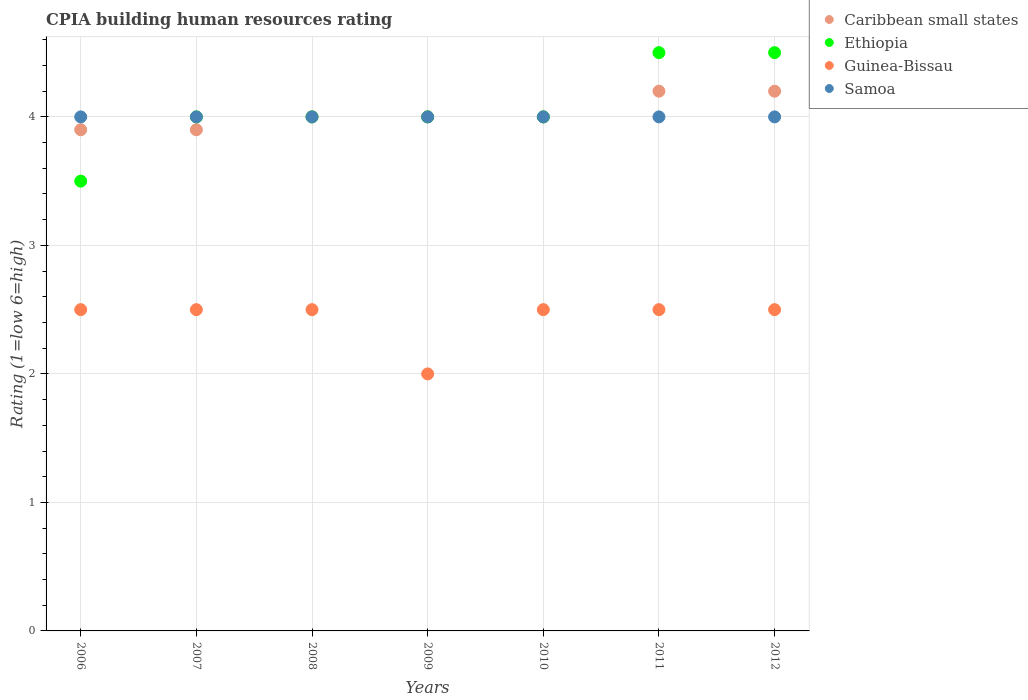How many different coloured dotlines are there?
Provide a succinct answer. 4. Is the number of dotlines equal to the number of legend labels?
Provide a short and direct response. Yes. What is the CPIA rating in Caribbean small states in 2010?
Offer a terse response. 4. Across all years, what is the maximum CPIA rating in Caribbean small states?
Ensure brevity in your answer.  4.2. Across all years, what is the minimum CPIA rating in Ethiopia?
Keep it short and to the point. 3.5. In which year was the CPIA rating in Samoa minimum?
Make the answer very short. 2006. What is the total CPIA rating in Guinea-Bissau in the graph?
Your response must be concise. 17. What is the average CPIA rating in Guinea-Bissau per year?
Your answer should be very brief. 2.43. In the year 2008, what is the difference between the CPIA rating in Guinea-Bissau and CPIA rating in Samoa?
Keep it short and to the point. -1.5. Is the CPIA rating in Ethiopia in 2006 less than that in 2012?
Offer a terse response. Yes. Is the difference between the CPIA rating in Guinea-Bissau in 2006 and 2012 greater than the difference between the CPIA rating in Samoa in 2006 and 2012?
Provide a short and direct response. No. What is the difference between the highest and the second highest CPIA rating in Ethiopia?
Your response must be concise. 0. What is the difference between the highest and the lowest CPIA rating in Guinea-Bissau?
Give a very brief answer. 0.5. Is it the case that in every year, the sum of the CPIA rating in Samoa and CPIA rating in Ethiopia  is greater than the sum of CPIA rating in Guinea-Bissau and CPIA rating in Caribbean small states?
Provide a succinct answer. No. Is it the case that in every year, the sum of the CPIA rating in Ethiopia and CPIA rating in Guinea-Bissau  is greater than the CPIA rating in Caribbean small states?
Your response must be concise. Yes. Does the CPIA rating in Caribbean small states monotonically increase over the years?
Offer a terse response. No. How many years are there in the graph?
Your response must be concise. 7. What is the difference between two consecutive major ticks on the Y-axis?
Offer a terse response. 1. Does the graph contain any zero values?
Offer a terse response. No. Does the graph contain grids?
Provide a succinct answer. Yes. Where does the legend appear in the graph?
Your response must be concise. Top right. How many legend labels are there?
Make the answer very short. 4. How are the legend labels stacked?
Keep it short and to the point. Vertical. What is the title of the graph?
Provide a succinct answer. CPIA building human resources rating. What is the label or title of the X-axis?
Provide a succinct answer. Years. What is the label or title of the Y-axis?
Provide a succinct answer. Rating (1=low 6=high). What is the Rating (1=low 6=high) of Guinea-Bissau in 2007?
Ensure brevity in your answer.  2.5. What is the Rating (1=low 6=high) in Caribbean small states in 2008?
Keep it short and to the point. 4. What is the Rating (1=low 6=high) in Samoa in 2008?
Your answer should be very brief. 4. What is the Rating (1=low 6=high) in Samoa in 2009?
Make the answer very short. 4. What is the Rating (1=low 6=high) in Guinea-Bissau in 2010?
Your response must be concise. 2.5. What is the Rating (1=low 6=high) in Ethiopia in 2011?
Provide a short and direct response. 4.5. What is the Rating (1=low 6=high) of Guinea-Bissau in 2011?
Ensure brevity in your answer.  2.5. What is the Rating (1=low 6=high) in Samoa in 2011?
Your response must be concise. 4. What is the Rating (1=low 6=high) in Guinea-Bissau in 2012?
Offer a very short reply. 2.5. What is the Rating (1=low 6=high) in Samoa in 2012?
Keep it short and to the point. 4. Across all years, what is the maximum Rating (1=low 6=high) of Guinea-Bissau?
Your response must be concise. 2.5. Across all years, what is the maximum Rating (1=low 6=high) of Samoa?
Provide a short and direct response. 4. Across all years, what is the minimum Rating (1=low 6=high) of Caribbean small states?
Your response must be concise. 3.9. Across all years, what is the minimum Rating (1=low 6=high) in Samoa?
Give a very brief answer. 4. What is the total Rating (1=low 6=high) of Caribbean small states in the graph?
Ensure brevity in your answer.  28.2. What is the total Rating (1=low 6=high) in Ethiopia in the graph?
Make the answer very short. 28.5. What is the total Rating (1=low 6=high) in Guinea-Bissau in the graph?
Your answer should be very brief. 17. What is the total Rating (1=low 6=high) in Samoa in the graph?
Offer a very short reply. 28. What is the difference between the Rating (1=low 6=high) of Ethiopia in 2006 and that in 2007?
Your answer should be very brief. -0.5. What is the difference between the Rating (1=low 6=high) of Guinea-Bissau in 2006 and that in 2007?
Provide a short and direct response. 0. What is the difference between the Rating (1=low 6=high) in Caribbean small states in 2006 and that in 2008?
Your answer should be compact. -0.1. What is the difference between the Rating (1=low 6=high) of Ethiopia in 2006 and that in 2008?
Provide a succinct answer. -0.5. What is the difference between the Rating (1=low 6=high) of Samoa in 2006 and that in 2008?
Your answer should be very brief. 0. What is the difference between the Rating (1=low 6=high) in Caribbean small states in 2006 and that in 2009?
Keep it short and to the point. -0.1. What is the difference between the Rating (1=low 6=high) in Ethiopia in 2006 and that in 2009?
Your answer should be very brief. -0.5. What is the difference between the Rating (1=low 6=high) of Samoa in 2006 and that in 2009?
Keep it short and to the point. 0. What is the difference between the Rating (1=low 6=high) of Guinea-Bissau in 2006 and that in 2010?
Offer a terse response. 0. What is the difference between the Rating (1=low 6=high) of Samoa in 2006 and that in 2010?
Ensure brevity in your answer.  0. What is the difference between the Rating (1=low 6=high) in Ethiopia in 2006 and that in 2011?
Your answer should be very brief. -1. What is the difference between the Rating (1=low 6=high) in Samoa in 2006 and that in 2011?
Provide a succinct answer. 0. What is the difference between the Rating (1=low 6=high) in Guinea-Bissau in 2006 and that in 2012?
Ensure brevity in your answer.  0. What is the difference between the Rating (1=low 6=high) in Samoa in 2006 and that in 2012?
Provide a succinct answer. 0. What is the difference between the Rating (1=low 6=high) in Ethiopia in 2007 and that in 2008?
Your response must be concise. 0. What is the difference between the Rating (1=low 6=high) of Samoa in 2007 and that in 2008?
Make the answer very short. 0. What is the difference between the Rating (1=low 6=high) in Caribbean small states in 2007 and that in 2009?
Ensure brevity in your answer.  -0.1. What is the difference between the Rating (1=low 6=high) of Ethiopia in 2007 and that in 2009?
Ensure brevity in your answer.  0. What is the difference between the Rating (1=low 6=high) of Caribbean small states in 2007 and that in 2010?
Give a very brief answer. -0.1. What is the difference between the Rating (1=low 6=high) in Ethiopia in 2007 and that in 2010?
Provide a succinct answer. 0. What is the difference between the Rating (1=low 6=high) of Guinea-Bissau in 2007 and that in 2010?
Your answer should be very brief. 0. What is the difference between the Rating (1=low 6=high) of Samoa in 2007 and that in 2010?
Your response must be concise. 0. What is the difference between the Rating (1=low 6=high) in Caribbean small states in 2007 and that in 2011?
Your answer should be compact. -0.3. What is the difference between the Rating (1=low 6=high) in Guinea-Bissau in 2007 and that in 2011?
Your answer should be very brief. 0. What is the difference between the Rating (1=low 6=high) in Samoa in 2007 and that in 2011?
Your answer should be compact. 0. What is the difference between the Rating (1=low 6=high) of Caribbean small states in 2007 and that in 2012?
Provide a succinct answer. -0.3. What is the difference between the Rating (1=low 6=high) of Ethiopia in 2007 and that in 2012?
Your answer should be compact. -0.5. What is the difference between the Rating (1=low 6=high) in Guinea-Bissau in 2007 and that in 2012?
Your response must be concise. 0. What is the difference between the Rating (1=low 6=high) of Samoa in 2007 and that in 2012?
Your answer should be very brief. 0. What is the difference between the Rating (1=low 6=high) of Caribbean small states in 2008 and that in 2009?
Offer a very short reply. 0. What is the difference between the Rating (1=low 6=high) in Guinea-Bissau in 2008 and that in 2010?
Provide a succinct answer. 0. What is the difference between the Rating (1=low 6=high) of Caribbean small states in 2008 and that in 2011?
Make the answer very short. -0.2. What is the difference between the Rating (1=low 6=high) in Guinea-Bissau in 2008 and that in 2011?
Ensure brevity in your answer.  0. What is the difference between the Rating (1=low 6=high) in Caribbean small states in 2008 and that in 2012?
Give a very brief answer. -0.2. What is the difference between the Rating (1=low 6=high) of Ethiopia in 2008 and that in 2012?
Ensure brevity in your answer.  -0.5. What is the difference between the Rating (1=low 6=high) in Guinea-Bissau in 2008 and that in 2012?
Offer a very short reply. 0. What is the difference between the Rating (1=low 6=high) in Samoa in 2008 and that in 2012?
Offer a terse response. 0. What is the difference between the Rating (1=low 6=high) in Caribbean small states in 2009 and that in 2010?
Make the answer very short. 0. What is the difference between the Rating (1=low 6=high) of Caribbean small states in 2009 and that in 2011?
Keep it short and to the point. -0.2. What is the difference between the Rating (1=low 6=high) in Ethiopia in 2009 and that in 2011?
Offer a terse response. -0.5. What is the difference between the Rating (1=low 6=high) of Caribbean small states in 2009 and that in 2012?
Keep it short and to the point. -0.2. What is the difference between the Rating (1=low 6=high) in Guinea-Bissau in 2009 and that in 2012?
Provide a short and direct response. -0.5. What is the difference between the Rating (1=low 6=high) in Guinea-Bissau in 2010 and that in 2011?
Your answer should be very brief. 0. What is the difference between the Rating (1=low 6=high) of Samoa in 2010 and that in 2012?
Your answer should be compact. 0. What is the difference between the Rating (1=low 6=high) in Ethiopia in 2011 and that in 2012?
Provide a succinct answer. 0. What is the difference between the Rating (1=low 6=high) of Samoa in 2011 and that in 2012?
Offer a very short reply. 0. What is the difference between the Rating (1=low 6=high) in Caribbean small states in 2006 and the Rating (1=low 6=high) in Ethiopia in 2007?
Make the answer very short. -0.1. What is the difference between the Rating (1=low 6=high) in Ethiopia in 2006 and the Rating (1=low 6=high) in Guinea-Bissau in 2007?
Keep it short and to the point. 1. What is the difference between the Rating (1=low 6=high) in Guinea-Bissau in 2006 and the Rating (1=low 6=high) in Samoa in 2007?
Provide a short and direct response. -1.5. What is the difference between the Rating (1=low 6=high) of Ethiopia in 2006 and the Rating (1=low 6=high) of Guinea-Bissau in 2008?
Ensure brevity in your answer.  1. What is the difference between the Rating (1=low 6=high) in Ethiopia in 2006 and the Rating (1=low 6=high) in Samoa in 2008?
Ensure brevity in your answer.  -0.5. What is the difference between the Rating (1=low 6=high) of Caribbean small states in 2006 and the Rating (1=low 6=high) of Ethiopia in 2009?
Keep it short and to the point. -0.1. What is the difference between the Rating (1=low 6=high) in Caribbean small states in 2006 and the Rating (1=low 6=high) in Samoa in 2009?
Offer a very short reply. -0.1. What is the difference between the Rating (1=low 6=high) in Ethiopia in 2006 and the Rating (1=low 6=high) in Guinea-Bissau in 2009?
Offer a terse response. 1.5. What is the difference between the Rating (1=low 6=high) of Guinea-Bissau in 2006 and the Rating (1=low 6=high) of Samoa in 2009?
Ensure brevity in your answer.  -1.5. What is the difference between the Rating (1=low 6=high) in Ethiopia in 2006 and the Rating (1=low 6=high) in Guinea-Bissau in 2010?
Your answer should be compact. 1. What is the difference between the Rating (1=low 6=high) in Guinea-Bissau in 2006 and the Rating (1=low 6=high) in Samoa in 2010?
Provide a short and direct response. -1.5. What is the difference between the Rating (1=low 6=high) in Caribbean small states in 2006 and the Rating (1=low 6=high) in Ethiopia in 2011?
Provide a short and direct response. -0.6. What is the difference between the Rating (1=low 6=high) in Caribbean small states in 2006 and the Rating (1=low 6=high) in Guinea-Bissau in 2011?
Provide a succinct answer. 1.4. What is the difference between the Rating (1=low 6=high) in Caribbean small states in 2006 and the Rating (1=low 6=high) in Samoa in 2011?
Keep it short and to the point. -0.1. What is the difference between the Rating (1=low 6=high) of Ethiopia in 2006 and the Rating (1=low 6=high) of Guinea-Bissau in 2011?
Make the answer very short. 1. What is the difference between the Rating (1=low 6=high) of Ethiopia in 2006 and the Rating (1=low 6=high) of Samoa in 2011?
Ensure brevity in your answer.  -0.5. What is the difference between the Rating (1=low 6=high) of Guinea-Bissau in 2006 and the Rating (1=low 6=high) of Samoa in 2011?
Your answer should be very brief. -1.5. What is the difference between the Rating (1=low 6=high) in Caribbean small states in 2006 and the Rating (1=low 6=high) in Ethiopia in 2012?
Give a very brief answer. -0.6. What is the difference between the Rating (1=low 6=high) of Ethiopia in 2006 and the Rating (1=low 6=high) of Samoa in 2012?
Your answer should be compact. -0.5. What is the difference between the Rating (1=low 6=high) in Guinea-Bissau in 2006 and the Rating (1=low 6=high) in Samoa in 2012?
Offer a very short reply. -1.5. What is the difference between the Rating (1=low 6=high) of Caribbean small states in 2007 and the Rating (1=low 6=high) of Ethiopia in 2008?
Provide a succinct answer. -0.1. What is the difference between the Rating (1=low 6=high) of Caribbean small states in 2007 and the Rating (1=low 6=high) of Guinea-Bissau in 2008?
Provide a short and direct response. 1.4. What is the difference between the Rating (1=low 6=high) in Ethiopia in 2007 and the Rating (1=low 6=high) in Guinea-Bissau in 2008?
Offer a very short reply. 1.5. What is the difference between the Rating (1=low 6=high) of Ethiopia in 2007 and the Rating (1=low 6=high) of Samoa in 2008?
Offer a terse response. 0. What is the difference between the Rating (1=low 6=high) in Guinea-Bissau in 2007 and the Rating (1=low 6=high) in Samoa in 2008?
Keep it short and to the point. -1.5. What is the difference between the Rating (1=low 6=high) of Caribbean small states in 2007 and the Rating (1=low 6=high) of Guinea-Bissau in 2009?
Give a very brief answer. 1.9. What is the difference between the Rating (1=low 6=high) of Caribbean small states in 2007 and the Rating (1=low 6=high) of Samoa in 2009?
Give a very brief answer. -0.1. What is the difference between the Rating (1=low 6=high) in Ethiopia in 2007 and the Rating (1=low 6=high) in Samoa in 2009?
Give a very brief answer. 0. What is the difference between the Rating (1=low 6=high) in Guinea-Bissau in 2007 and the Rating (1=low 6=high) in Samoa in 2009?
Provide a short and direct response. -1.5. What is the difference between the Rating (1=low 6=high) in Caribbean small states in 2007 and the Rating (1=low 6=high) in Ethiopia in 2010?
Your response must be concise. -0.1. What is the difference between the Rating (1=low 6=high) of Caribbean small states in 2007 and the Rating (1=low 6=high) of Guinea-Bissau in 2010?
Offer a terse response. 1.4. What is the difference between the Rating (1=low 6=high) in Caribbean small states in 2007 and the Rating (1=low 6=high) in Samoa in 2010?
Provide a succinct answer. -0.1. What is the difference between the Rating (1=low 6=high) of Ethiopia in 2007 and the Rating (1=low 6=high) of Guinea-Bissau in 2010?
Your response must be concise. 1.5. What is the difference between the Rating (1=low 6=high) in Ethiopia in 2007 and the Rating (1=low 6=high) in Samoa in 2010?
Your response must be concise. 0. What is the difference between the Rating (1=low 6=high) in Ethiopia in 2007 and the Rating (1=low 6=high) in Guinea-Bissau in 2011?
Your answer should be very brief. 1.5. What is the difference between the Rating (1=low 6=high) in Guinea-Bissau in 2007 and the Rating (1=low 6=high) in Samoa in 2011?
Your answer should be compact. -1.5. What is the difference between the Rating (1=low 6=high) of Ethiopia in 2007 and the Rating (1=low 6=high) of Samoa in 2012?
Make the answer very short. 0. What is the difference between the Rating (1=low 6=high) in Guinea-Bissau in 2007 and the Rating (1=low 6=high) in Samoa in 2012?
Keep it short and to the point. -1.5. What is the difference between the Rating (1=low 6=high) in Caribbean small states in 2008 and the Rating (1=low 6=high) in Ethiopia in 2009?
Keep it short and to the point. 0. What is the difference between the Rating (1=low 6=high) in Caribbean small states in 2008 and the Rating (1=low 6=high) in Guinea-Bissau in 2009?
Your response must be concise. 2. What is the difference between the Rating (1=low 6=high) in Ethiopia in 2008 and the Rating (1=low 6=high) in Guinea-Bissau in 2009?
Your answer should be very brief. 2. What is the difference between the Rating (1=low 6=high) in Ethiopia in 2008 and the Rating (1=low 6=high) in Samoa in 2009?
Keep it short and to the point. 0. What is the difference between the Rating (1=low 6=high) in Caribbean small states in 2008 and the Rating (1=low 6=high) in Samoa in 2010?
Your response must be concise. 0. What is the difference between the Rating (1=low 6=high) of Ethiopia in 2008 and the Rating (1=low 6=high) of Guinea-Bissau in 2010?
Your answer should be compact. 1.5. What is the difference between the Rating (1=low 6=high) in Caribbean small states in 2008 and the Rating (1=low 6=high) in Guinea-Bissau in 2011?
Give a very brief answer. 1.5. What is the difference between the Rating (1=low 6=high) of Caribbean small states in 2008 and the Rating (1=low 6=high) of Samoa in 2011?
Offer a very short reply. 0. What is the difference between the Rating (1=low 6=high) in Ethiopia in 2008 and the Rating (1=low 6=high) in Guinea-Bissau in 2011?
Keep it short and to the point. 1.5. What is the difference between the Rating (1=low 6=high) in Ethiopia in 2008 and the Rating (1=low 6=high) in Samoa in 2011?
Ensure brevity in your answer.  0. What is the difference between the Rating (1=low 6=high) of Caribbean small states in 2008 and the Rating (1=low 6=high) of Guinea-Bissau in 2012?
Ensure brevity in your answer.  1.5. What is the difference between the Rating (1=low 6=high) in Ethiopia in 2008 and the Rating (1=low 6=high) in Guinea-Bissau in 2012?
Provide a short and direct response. 1.5. What is the difference between the Rating (1=low 6=high) in Guinea-Bissau in 2008 and the Rating (1=low 6=high) in Samoa in 2012?
Your answer should be compact. -1.5. What is the difference between the Rating (1=low 6=high) of Caribbean small states in 2009 and the Rating (1=low 6=high) of Guinea-Bissau in 2010?
Your answer should be compact. 1.5. What is the difference between the Rating (1=low 6=high) in Caribbean small states in 2009 and the Rating (1=low 6=high) in Guinea-Bissau in 2011?
Provide a short and direct response. 1.5. What is the difference between the Rating (1=low 6=high) of Ethiopia in 2009 and the Rating (1=low 6=high) of Guinea-Bissau in 2011?
Your response must be concise. 1.5. What is the difference between the Rating (1=low 6=high) in Caribbean small states in 2009 and the Rating (1=low 6=high) in Ethiopia in 2012?
Provide a short and direct response. -0.5. What is the difference between the Rating (1=low 6=high) of Caribbean small states in 2009 and the Rating (1=low 6=high) of Samoa in 2012?
Give a very brief answer. 0. What is the difference between the Rating (1=low 6=high) in Ethiopia in 2009 and the Rating (1=low 6=high) in Guinea-Bissau in 2012?
Your answer should be compact. 1.5. What is the difference between the Rating (1=low 6=high) in Ethiopia in 2009 and the Rating (1=low 6=high) in Samoa in 2012?
Offer a very short reply. 0. What is the difference between the Rating (1=low 6=high) in Guinea-Bissau in 2009 and the Rating (1=low 6=high) in Samoa in 2012?
Keep it short and to the point. -2. What is the difference between the Rating (1=low 6=high) of Caribbean small states in 2010 and the Rating (1=low 6=high) of Guinea-Bissau in 2012?
Make the answer very short. 1.5. What is the difference between the Rating (1=low 6=high) in Caribbean small states in 2010 and the Rating (1=low 6=high) in Samoa in 2012?
Offer a terse response. 0. What is the difference between the Rating (1=low 6=high) in Ethiopia in 2010 and the Rating (1=low 6=high) in Samoa in 2012?
Your answer should be very brief. 0. What is the difference between the Rating (1=low 6=high) of Caribbean small states in 2011 and the Rating (1=low 6=high) of Guinea-Bissau in 2012?
Offer a terse response. 1.7. What is the difference between the Rating (1=low 6=high) of Caribbean small states in 2011 and the Rating (1=low 6=high) of Samoa in 2012?
Keep it short and to the point. 0.2. What is the difference between the Rating (1=low 6=high) of Ethiopia in 2011 and the Rating (1=low 6=high) of Guinea-Bissau in 2012?
Offer a terse response. 2. What is the difference between the Rating (1=low 6=high) of Ethiopia in 2011 and the Rating (1=low 6=high) of Samoa in 2012?
Ensure brevity in your answer.  0.5. What is the average Rating (1=low 6=high) of Caribbean small states per year?
Ensure brevity in your answer.  4.03. What is the average Rating (1=low 6=high) of Ethiopia per year?
Give a very brief answer. 4.07. What is the average Rating (1=low 6=high) in Guinea-Bissau per year?
Your answer should be compact. 2.43. What is the average Rating (1=low 6=high) in Samoa per year?
Offer a terse response. 4. In the year 2006, what is the difference between the Rating (1=low 6=high) of Caribbean small states and Rating (1=low 6=high) of Guinea-Bissau?
Offer a terse response. 1.4. In the year 2006, what is the difference between the Rating (1=low 6=high) of Ethiopia and Rating (1=low 6=high) of Guinea-Bissau?
Provide a short and direct response. 1. In the year 2006, what is the difference between the Rating (1=low 6=high) in Ethiopia and Rating (1=low 6=high) in Samoa?
Provide a short and direct response. -0.5. In the year 2006, what is the difference between the Rating (1=low 6=high) in Guinea-Bissau and Rating (1=low 6=high) in Samoa?
Your answer should be compact. -1.5. In the year 2007, what is the difference between the Rating (1=low 6=high) of Ethiopia and Rating (1=low 6=high) of Guinea-Bissau?
Offer a very short reply. 1.5. In the year 2008, what is the difference between the Rating (1=low 6=high) of Ethiopia and Rating (1=low 6=high) of Guinea-Bissau?
Keep it short and to the point. 1.5. In the year 2008, what is the difference between the Rating (1=low 6=high) in Guinea-Bissau and Rating (1=low 6=high) in Samoa?
Offer a very short reply. -1.5. In the year 2009, what is the difference between the Rating (1=low 6=high) of Caribbean small states and Rating (1=low 6=high) of Ethiopia?
Offer a terse response. 0. In the year 2009, what is the difference between the Rating (1=low 6=high) in Caribbean small states and Rating (1=low 6=high) in Samoa?
Offer a very short reply. 0. In the year 2009, what is the difference between the Rating (1=low 6=high) in Ethiopia and Rating (1=low 6=high) in Guinea-Bissau?
Offer a terse response. 2. In the year 2010, what is the difference between the Rating (1=low 6=high) in Caribbean small states and Rating (1=low 6=high) in Ethiopia?
Offer a very short reply. 0. In the year 2010, what is the difference between the Rating (1=low 6=high) in Caribbean small states and Rating (1=low 6=high) in Guinea-Bissau?
Provide a short and direct response. 1.5. In the year 2010, what is the difference between the Rating (1=low 6=high) of Ethiopia and Rating (1=low 6=high) of Guinea-Bissau?
Your answer should be compact. 1.5. In the year 2010, what is the difference between the Rating (1=low 6=high) of Guinea-Bissau and Rating (1=low 6=high) of Samoa?
Offer a very short reply. -1.5. In the year 2011, what is the difference between the Rating (1=low 6=high) of Ethiopia and Rating (1=low 6=high) of Guinea-Bissau?
Keep it short and to the point. 2. In the year 2011, what is the difference between the Rating (1=low 6=high) of Ethiopia and Rating (1=low 6=high) of Samoa?
Give a very brief answer. 0.5. In the year 2011, what is the difference between the Rating (1=low 6=high) of Guinea-Bissau and Rating (1=low 6=high) of Samoa?
Offer a very short reply. -1.5. In the year 2012, what is the difference between the Rating (1=low 6=high) in Caribbean small states and Rating (1=low 6=high) in Ethiopia?
Your answer should be very brief. -0.3. In the year 2012, what is the difference between the Rating (1=low 6=high) of Caribbean small states and Rating (1=low 6=high) of Samoa?
Give a very brief answer. 0.2. In the year 2012, what is the difference between the Rating (1=low 6=high) in Ethiopia and Rating (1=low 6=high) in Guinea-Bissau?
Offer a terse response. 2. In the year 2012, what is the difference between the Rating (1=low 6=high) in Ethiopia and Rating (1=low 6=high) in Samoa?
Ensure brevity in your answer.  0.5. What is the ratio of the Rating (1=low 6=high) of Caribbean small states in 2006 to that in 2007?
Give a very brief answer. 1. What is the ratio of the Rating (1=low 6=high) of Samoa in 2006 to that in 2007?
Your answer should be compact. 1. What is the ratio of the Rating (1=low 6=high) in Ethiopia in 2006 to that in 2008?
Give a very brief answer. 0.88. What is the ratio of the Rating (1=low 6=high) of Guinea-Bissau in 2006 to that in 2008?
Provide a succinct answer. 1. What is the ratio of the Rating (1=low 6=high) in Caribbean small states in 2006 to that in 2009?
Keep it short and to the point. 0.97. What is the ratio of the Rating (1=low 6=high) of Samoa in 2006 to that in 2009?
Make the answer very short. 1. What is the ratio of the Rating (1=low 6=high) of Caribbean small states in 2006 to that in 2010?
Ensure brevity in your answer.  0.97. What is the ratio of the Rating (1=low 6=high) in Guinea-Bissau in 2006 to that in 2010?
Ensure brevity in your answer.  1. What is the ratio of the Rating (1=low 6=high) in Samoa in 2006 to that in 2010?
Keep it short and to the point. 1. What is the ratio of the Rating (1=low 6=high) of Ethiopia in 2006 to that in 2011?
Your response must be concise. 0.78. What is the ratio of the Rating (1=low 6=high) in Guinea-Bissau in 2006 to that in 2012?
Give a very brief answer. 1. What is the ratio of the Rating (1=low 6=high) of Caribbean small states in 2007 to that in 2008?
Your answer should be very brief. 0.97. What is the ratio of the Rating (1=low 6=high) of Ethiopia in 2007 to that in 2008?
Provide a short and direct response. 1. What is the ratio of the Rating (1=low 6=high) of Guinea-Bissau in 2007 to that in 2008?
Make the answer very short. 1. What is the ratio of the Rating (1=low 6=high) in Caribbean small states in 2007 to that in 2009?
Provide a short and direct response. 0.97. What is the ratio of the Rating (1=low 6=high) of Ethiopia in 2007 to that in 2009?
Ensure brevity in your answer.  1. What is the ratio of the Rating (1=low 6=high) of Guinea-Bissau in 2007 to that in 2009?
Make the answer very short. 1.25. What is the ratio of the Rating (1=low 6=high) in Samoa in 2007 to that in 2009?
Give a very brief answer. 1. What is the ratio of the Rating (1=low 6=high) of Ethiopia in 2007 to that in 2011?
Provide a short and direct response. 0.89. What is the ratio of the Rating (1=low 6=high) in Caribbean small states in 2007 to that in 2012?
Provide a short and direct response. 0.93. What is the ratio of the Rating (1=low 6=high) of Guinea-Bissau in 2007 to that in 2012?
Provide a short and direct response. 1. What is the ratio of the Rating (1=low 6=high) of Ethiopia in 2008 to that in 2009?
Provide a short and direct response. 1. What is the ratio of the Rating (1=low 6=high) in Samoa in 2008 to that in 2009?
Provide a short and direct response. 1. What is the ratio of the Rating (1=low 6=high) in Caribbean small states in 2008 to that in 2010?
Ensure brevity in your answer.  1. What is the ratio of the Rating (1=low 6=high) in Ethiopia in 2008 to that in 2010?
Your answer should be very brief. 1. What is the ratio of the Rating (1=low 6=high) of Guinea-Bissau in 2008 to that in 2010?
Your answer should be very brief. 1. What is the ratio of the Rating (1=low 6=high) in Caribbean small states in 2008 to that in 2011?
Provide a succinct answer. 0.95. What is the ratio of the Rating (1=low 6=high) of Ethiopia in 2008 to that in 2011?
Ensure brevity in your answer.  0.89. What is the ratio of the Rating (1=low 6=high) in Guinea-Bissau in 2008 to that in 2011?
Your answer should be compact. 1. What is the ratio of the Rating (1=low 6=high) of Guinea-Bissau in 2008 to that in 2012?
Give a very brief answer. 1. What is the ratio of the Rating (1=low 6=high) in Samoa in 2008 to that in 2012?
Provide a succinct answer. 1. What is the ratio of the Rating (1=low 6=high) of Caribbean small states in 2009 to that in 2010?
Your response must be concise. 1. What is the ratio of the Rating (1=low 6=high) of Samoa in 2009 to that in 2010?
Make the answer very short. 1. What is the ratio of the Rating (1=low 6=high) of Ethiopia in 2009 to that in 2011?
Provide a succinct answer. 0.89. What is the ratio of the Rating (1=low 6=high) in Caribbean small states in 2009 to that in 2012?
Your response must be concise. 0.95. What is the ratio of the Rating (1=low 6=high) of Ethiopia in 2009 to that in 2012?
Your answer should be very brief. 0.89. What is the ratio of the Rating (1=low 6=high) of Guinea-Bissau in 2009 to that in 2012?
Ensure brevity in your answer.  0.8. What is the ratio of the Rating (1=low 6=high) in Samoa in 2009 to that in 2012?
Keep it short and to the point. 1. What is the ratio of the Rating (1=low 6=high) of Caribbean small states in 2010 to that in 2011?
Offer a very short reply. 0.95. What is the ratio of the Rating (1=low 6=high) in Guinea-Bissau in 2010 to that in 2011?
Make the answer very short. 1. What is the ratio of the Rating (1=low 6=high) of Caribbean small states in 2011 to that in 2012?
Ensure brevity in your answer.  1. What is the ratio of the Rating (1=low 6=high) of Ethiopia in 2011 to that in 2012?
Offer a terse response. 1. What is the ratio of the Rating (1=low 6=high) in Guinea-Bissau in 2011 to that in 2012?
Your answer should be very brief. 1. What is the difference between the highest and the second highest Rating (1=low 6=high) in Caribbean small states?
Give a very brief answer. 0. What is the difference between the highest and the second highest Rating (1=low 6=high) in Samoa?
Give a very brief answer. 0. What is the difference between the highest and the lowest Rating (1=low 6=high) of Ethiopia?
Your answer should be compact. 1. What is the difference between the highest and the lowest Rating (1=low 6=high) in Guinea-Bissau?
Give a very brief answer. 0.5. What is the difference between the highest and the lowest Rating (1=low 6=high) in Samoa?
Your answer should be very brief. 0. 